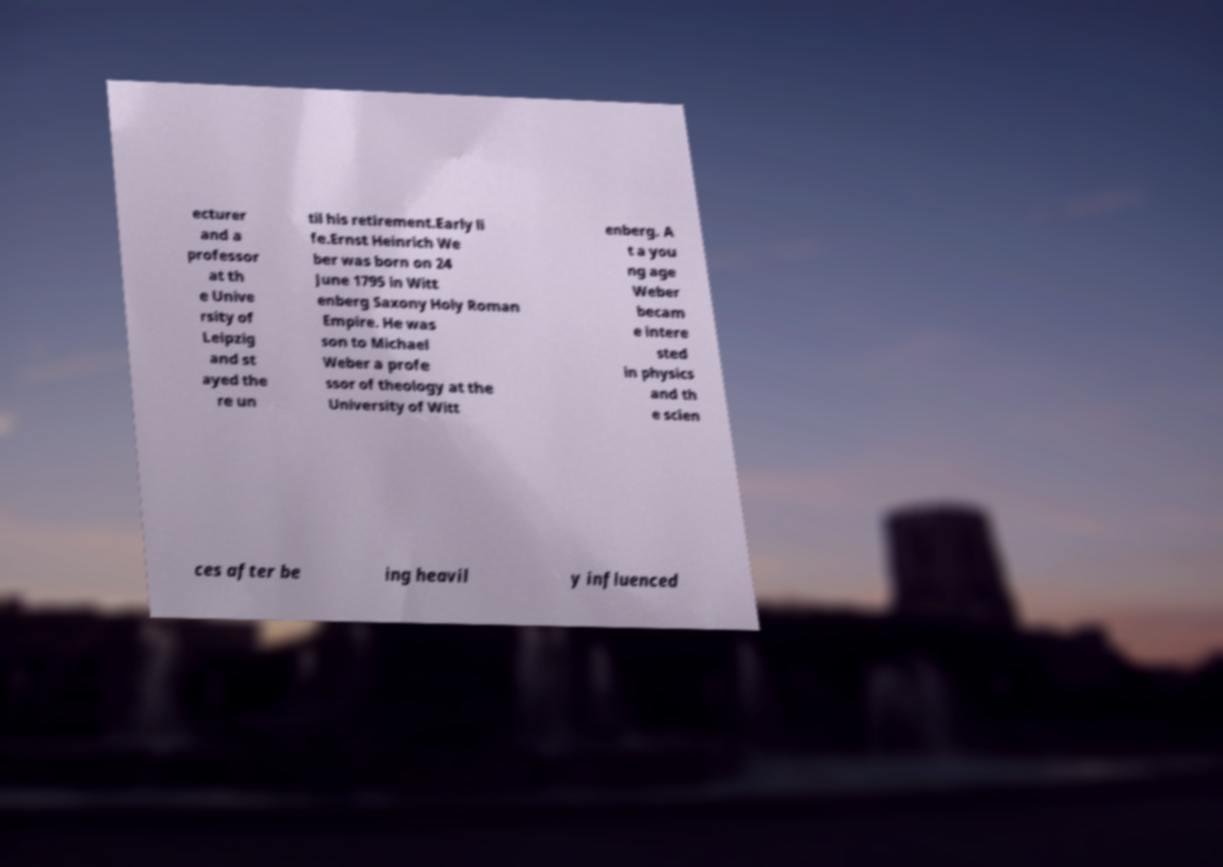Could you extract and type out the text from this image? ecturer and a professor at th e Unive rsity of Leipzig and st ayed the re un til his retirement.Early li fe.Ernst Heinrich We ber was born on 24 June 1795 in Witt enberg Saxony Holy Roman Empire. He was son to Michael Weber a profe ssor of theology at the University of Witt enberg. A t a you ng age Weber becam e intere sted in physics and th e scien ces after be ing heavil y influenced 